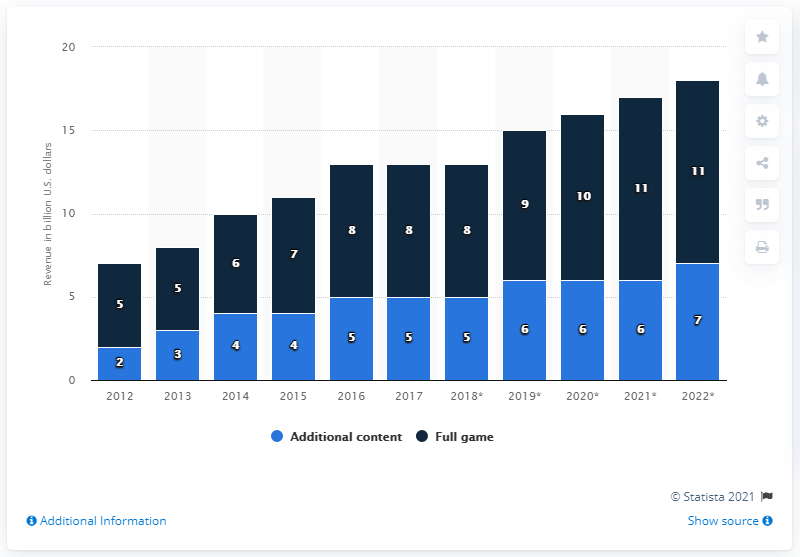Identify some key points in this picture. The maximum difference between the sale of additional content and the full game was in the year 2021. In 2022, the highest revenue was generated by selling PC and console games. 